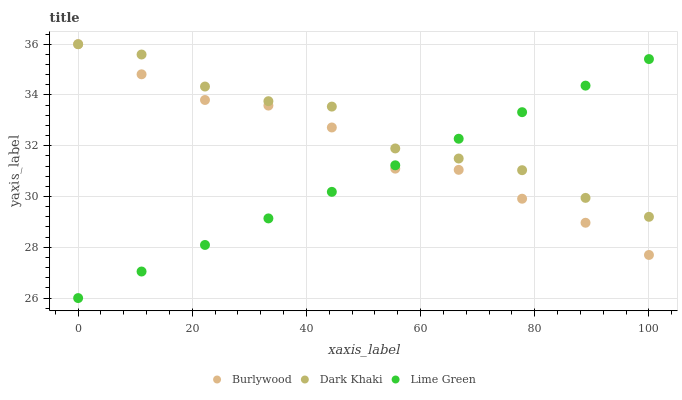Does Lime Green have the minimum area under the curve?
Answer yes or no. Yes. Does Dark Khaki have the maximum area under the curve?
Answer yes or no. Yes. Does Dark Khaki have the minimum area under the curve?
Answer yes or no. No. Does Lime Green have the maximum area under the curve?
Answer yes or no. No. Is Lime Green the smoothest?
Answer yes or no. Yes. Is Dark Khaki the roughest?
Answer yes or no. Yes. Is Dark Khaki the smoothest?
Answer yes or no. No. Is Lime Green the roughest?
Answer yes or no. No. Does Lime Green have the lowest value?
Answer yes or no. Yes. Does Dark Khaki have the lowest value?
Answer yes or no. No. Does Dark Khaki have the highest value?
Answer yes or no. Yes. Does Lime Green have the highest value?
Answer yes or no. No. Does Lime Green intersect Burlywood?
Answer yes or no. Yes. Is Lime Green less than Burlywood?
Answer yes or no. No. Is Lime Green greater than Burlywood?
Answer yes or no. No. 